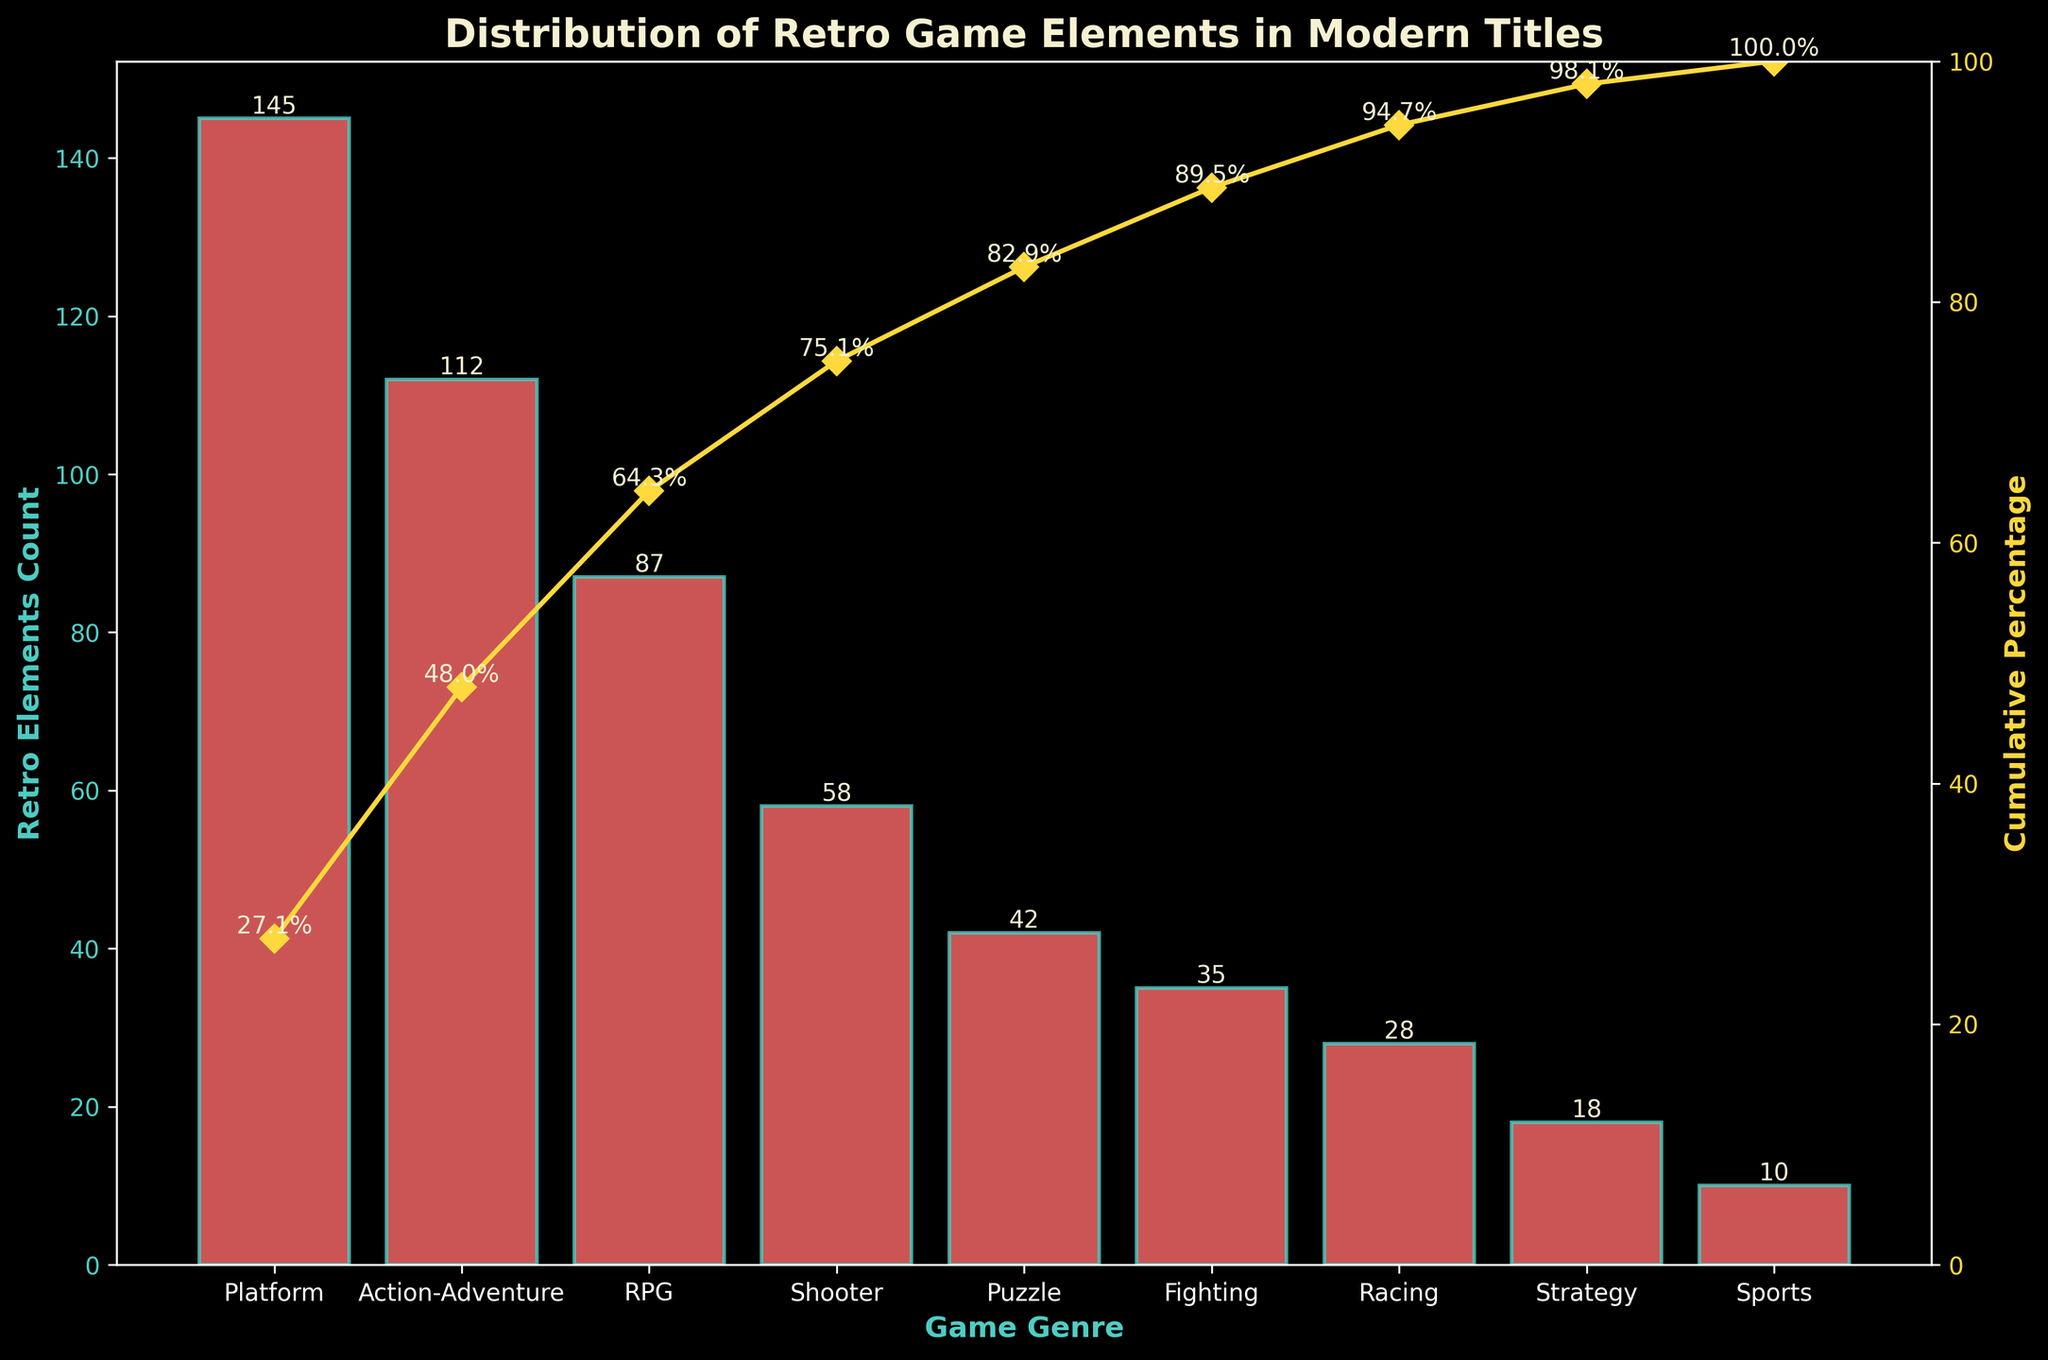What is the title of the chart? The title of the chart is displayed at the top of the figure in a larger font, often in bold. In this case, it reads "Distribution of Retro Game Elements in Modern Titles".
Answer: Distribution of Retro Game Elements in Modern Titles Which game genre has the highest count of retro elements? By observing the height of the bars, we can see that the genre 'Platform' has the tallest bar, indicating it has the highest count of retro elements.
Answer: Platform What is the cumulative percentage for the 'Shooter' genre? By looking along the line plot that depicts the cumulative percentages, we find that the data point for 'Shooter' is labeled with '75.1%'.
Answer: 75.1% How many game genres have a retro elements count above 50? To determine this, we count the number of bars that are taller than the threshold representing 50. The genres 'Platform', 'Action-Adventure', 'RPG', and 'Shooter' all meet this criterion.
Answer: 4 Which genre shows a cumulative percentage of exactly 100%? Observing the end of the cumulative percentage line, the last data point corresponding to 'Sports' genre clearly displays a cumulative percentage of '100%'.
Answer: Sports How many retro elements are there in total across all genres? Adding up the retro elements counts for all the genres: 145 + 112 + 87 + 58 + 42 + 35 + 28 + 18 + 10, the total is 535.
Answer: 535 What's the difference in the cumulative percentage between 'Puzzle' and 'Racing' genres? The cumulative percentage for 'Puzzle' is 82.9% and for 'Racing' is 94.7%. Subtracting these gives us 94.7 - 82.9 = 11.8%.
Answer: 11.8% Which genre shows a sharp increase in cumulative percentage compared to its previous genre? The plot clearly shows a noticeable increase between 'Platform' with 27.1% and 'Action-Adventure' with 48.0%. This jump is significant and larger than increases between other consecutive genres.
Answer: Action-Adventure How does the retro element count for 'Fighting' compare to 'Strategy'? Looking at the heights of the respective bars, 'Fighting' with 35 is greater than 'Strategy' which has 18.
Answer: Fighting has more retro elements 